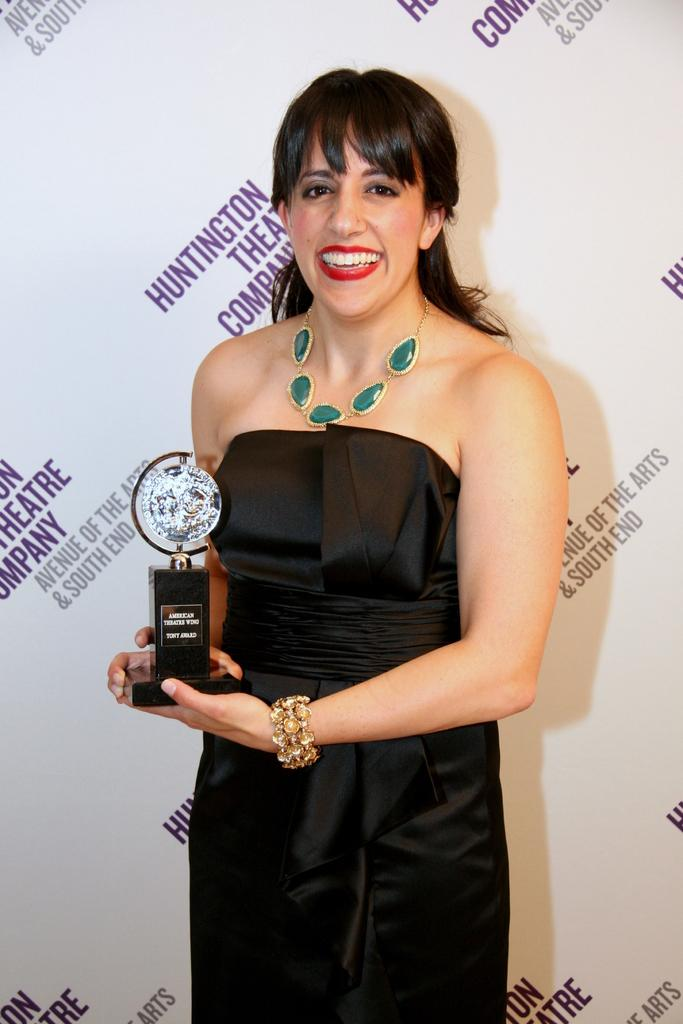What is present in the image? There is a person in the image. What is the person wearing? The person is wearing clothes. What is the person holding in the image? The person is holding an award with her hands. What is the purpose of the car in the image? There is no car present in the image. 